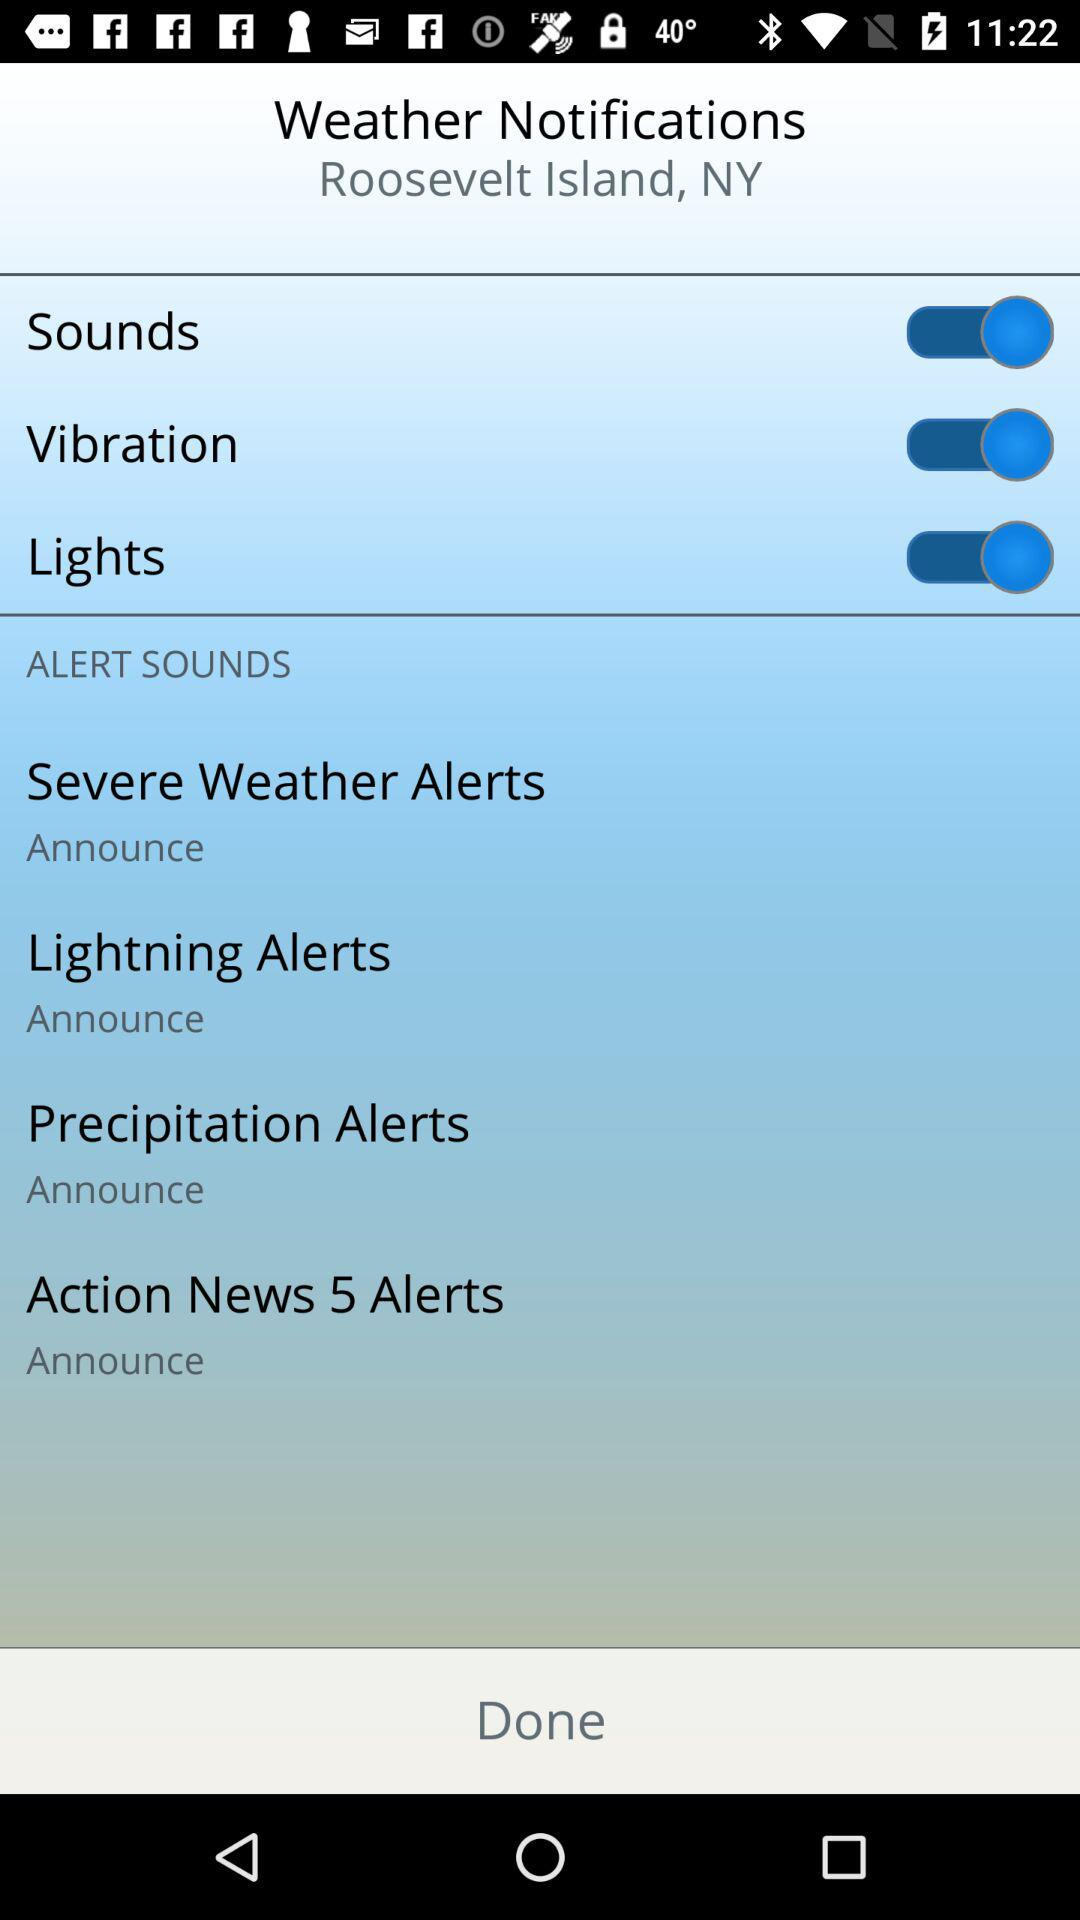What is the status of sounds? The status is on. 